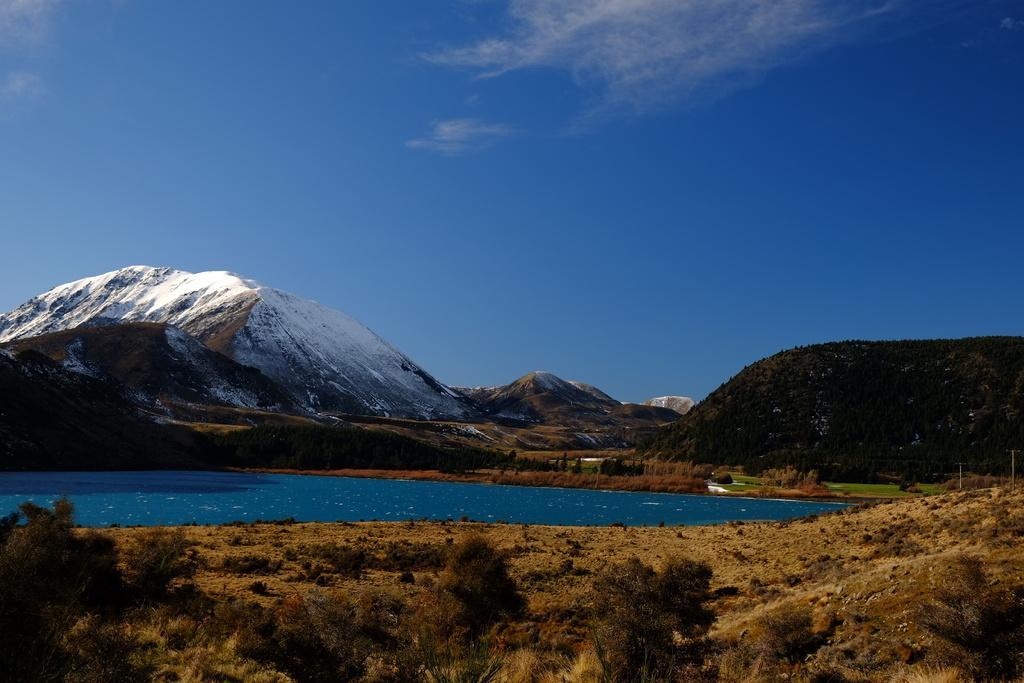Can you describe this image briefly? In the center of the image there is a lake. At the bottom there are shrubs. In the background there are hills and sky. 